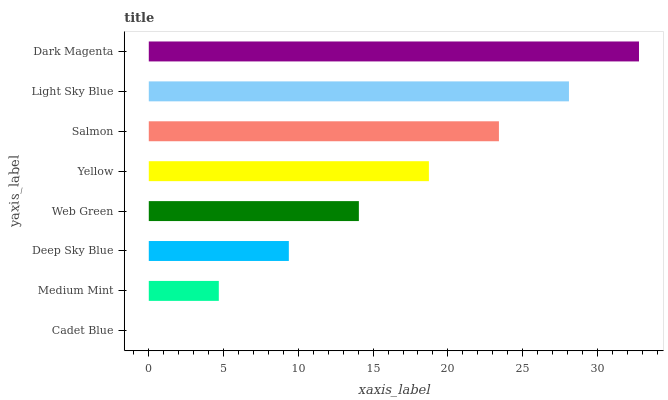Is Cadet Blue the minimum?
Answer yes or no. Yes. Is Dark Magenta the maximum?
Answer yes or no. Yes. Is Medium Mint the minimum?
Answer yes or no. No. Is Medium Mint the maximum?
Answer yes or no. No. Is Medium Mint greater than Cadet Blue?
Answer yes or no. Yes. Is Cadet Blue less than Medium Mint?
Answer yes or no. Yes. Is Cadet Blue greater than Medium Mint?
Answer yes or no. No. Is Medium Mint less than Cadet Blue?
Answer yes or no. No. Is Yellow the high median?
Answer yes or no. Yes. Is Web Green the low median?
Answer yes or no. Yes. Is Dark Magenta the high median?
Answer yes or no. No. Is Deep Sky Blue the low median?
Answer yes or no. No. 